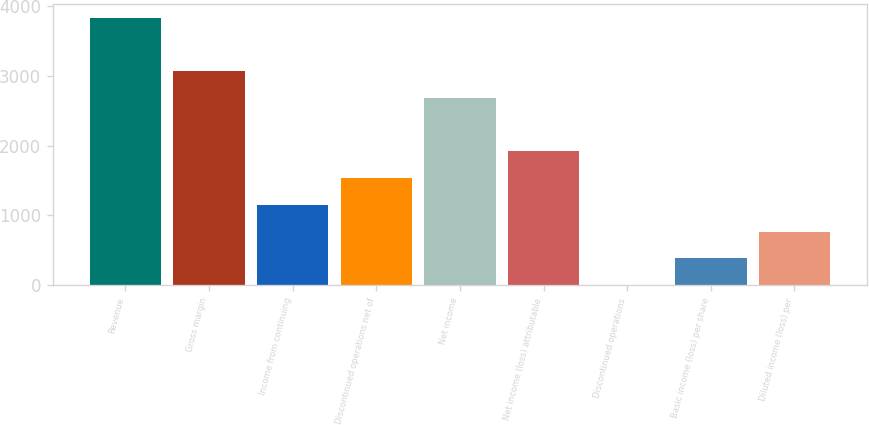Convert chart to OTSL. <chart><loc_0><loc_0><loc_500><loc_500><bar_chart><fcel>Revenue<fcel>Gross margin<fcel>Income from continuing<fcel>Discontinued operations net of<fcel>Net income<fcel>Net income (loss) attributable<fcel>Discontinued operations<fcel>Basic income (loss) per share<fcel>Diluted income (loss) per<nl><fcel>3838<fcel>3070.41<fcel>1151.41<fcel>1535.21<fcel>2686.61<fcel>1919.01<fcel>0.01<fcel>383.81<fcel>767.61<nl></chart> 